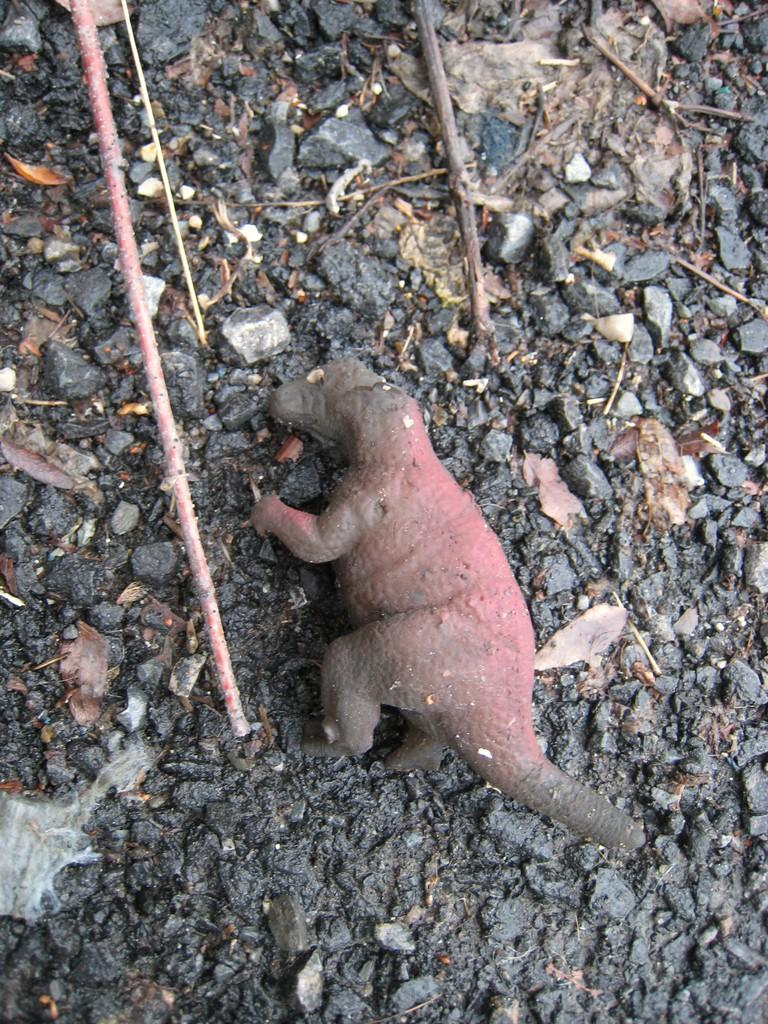What type of animal can be seen in the image? There is an animal in the image, but its specific type cannot be determined from the provided facts. What can be found on the ground in the image? There are stones, leaves, and sticks on the ground in the image. What type of muscle is visible on the animal in the image? There is no muscle visible on the animal in the image, as the specific type of animal cannot be determined from the provided facts. What type of metal can be seen in the image? There is no metal present in the image; it features an animal, stones, leaves, and sticks. 